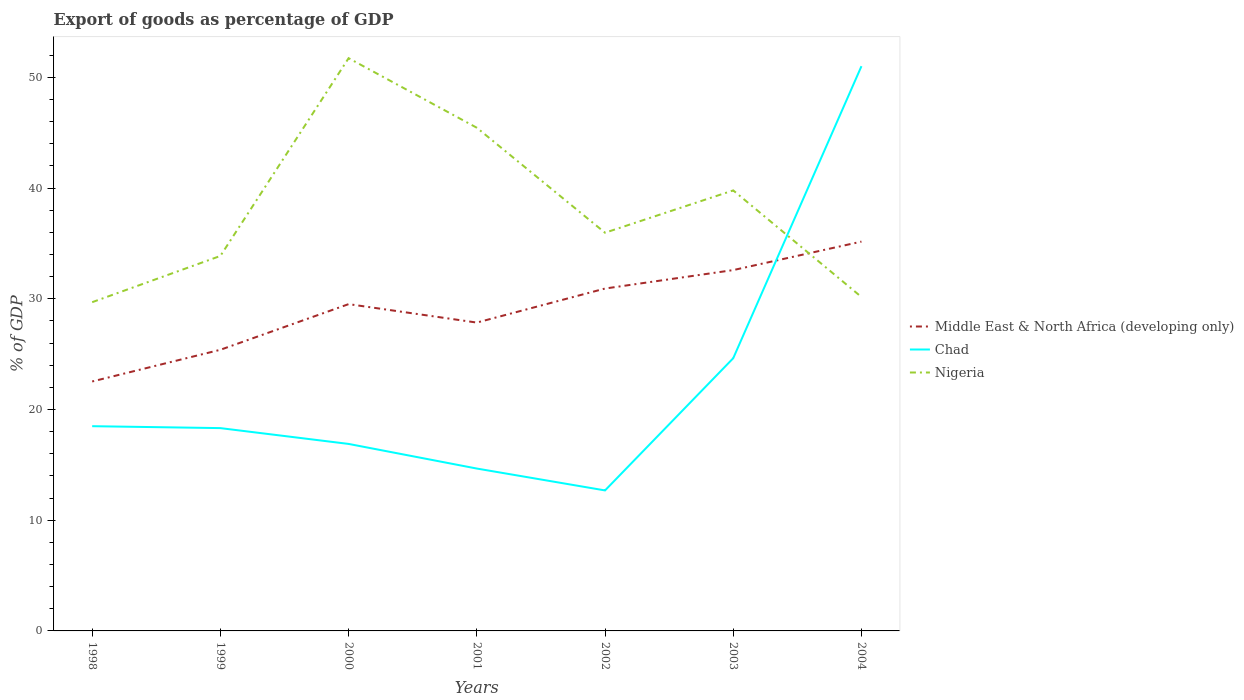Does the line corresponding to Nigeria intersect with the line corresponding to Middle East & North Africa (developing only)?
Give a very brief answer. Yes. Is the number of lines equal to the number of legend labels?
Your response must be concise. Yes. Across all years, what is the maximum export of goods as percentage of GDP in Middle East & North Africa (developing only)?
Give a very brief answer. 22.53. In which year was the export of goods as percentage of GDP in Chad maximum?
Keep it short and to the point. 2002. What is the total export of goods as percentage of GDP in Middle East & North Africa (developing only) in the graph?
Your answer should be very brief. -1.67. What is the difference between the highest and the second highest export of goods as percentage of GDP in Chad?
Your answer should be compact. 38.32. Does the graph contain grids?
Provide a succinct answer. No. How many legend labels are there?
Provide a succinct answer. 3. What is the title of the graph?
Your answer should be compact. Export of goods as percentage of GDP. What is the label or title of the X-axis?
Give a very brief answer. Years. What is the label or title of the Y-axis?
Make the answer very short. % of GDP. What is the % of GDP in Middle East & North Africa (developing only) in 1998?
Ensure brevity in your answer.  22.53. What is the % of GDP of Chad in 1998?
Make the answer very short. 18.49. What is the % of GDP in Nigeria in 1998?
Provide a succinct answer. 29.69. What is the % of GDP in Middle East & North Africa (developing only) in 1999?
Keep it short and to the point. 25.39. What is the % of GDP of Chad in 1999?
Your response must be concise. 18.32. What is the % of GDP of Nigeria in 1999?
Make the answer very short. 33.87. What is the % of GDP of Middle East & North Africa (developing only) in 2000?
Give a very brief answer. 29.52. What is the % of GDP in Chad in 2000?
Make the answer very short. 16.89. What is the % of GDP of Nigeria in 2000?
Keep it short and to the point. 51.73. What is the % of GDP in Middle East & North Africa (developing only) in 2001?
Your answer should be very brief. 27.85. What is the % of GDP in Chad in 2001?
Offer a terse response. 14.67. What is the % of GDP in Nigeria in 2001?
Your response must be concise. 45.45. What is the % of GDP in Middle East & North Africa (developing only) in 2002?
Offer a very short reply. 30.92. What is the % of GDP in Chad in 2002?
Your response must be concise. 12.69. What is the % of GDP in Nigeria in 2002?
Keep it short and to the point. 35.97. What is the % of GDP in Middle East & North Africa (developing only) in 2003?
Ensure brevity in your answer.  32.59. What is the % of GDP in Chad in 2003?
Your response must be concise. 24.63. What is the % of GDP of Nigeria in 2003?
Provide a succinct answer. 39.79. What is the % of GDP of Middle East & North Africa (developing only) in 2004?
Keep it short and to the point. 35.16. What is the % of GDP in Chad in 2004?
Keep it short and to the point. 51.01. What is the % of GDP of Nigeria in 2004?
Provide a succinct answer. 30.16. Across all years, what is the maximum % of GDP of Middle East & North Africa (developing only)?
Offer a very short reply. 35.16. Across all years, what is the maximum % of GDP of Chad?
Ensure brevity in your answer.  51.01. Across all years, what is the maximum % of GDP of Nigeria?
Provide a succinct answer. 51.73. Across all years, what is the minimum % of GDP of Middle East & North Africa (developing only)?
Provide a short and direct response. 22.53. Across all years, what is the minimum % of GDP in Chad?
Your response must be concise. 12.69. Across all years, what is the minimum % of GDP in Nigeria?
Offer a very short reply. 29.69. What is the total % of GDP of Middle East & North Africa (developing only) in the graph?
Ensure brevity in your answer.  203.97. What is the total % of GDP in Chad in the graph?
Offer a terse response. 156.7. What is the total % of GDP in Nigeria in the graph?
Provide a succinct answer. 266.65. What is the difference between the % of GDP of Middle East & North Africa (developing only) in 1998 and that in 1999?
Offer a very short reply. -2.86. What is the difference between the % of GDP of Chad in 1998 and that in 1999?
Ensure brevity in your answer.  0.17. What is the difference between the % of GDP of Nigeria in 1998 and that in 1999?
Give a very brief answer. -4.18. What is the difference between the % of GDP of Middle East & North Africa (developing only) in 1998 and that in 2000?
Offer a very short reply. -6.99. What is the difference between the % of GDP in Chad in 1998 and that in 2000?
Keep it short and to the point. 1.6. What is the difference between the % of GDP of Nigeria in 1998 and that in 2000?
Provide a short and direct response. -22.04. What is the difference between the % of GDP in Middle East & North Africa (developing only) in 1998 and that in 2001?
Give a very brief answer. -5.32. What is the difference between the % of GDP of Chad in 1998 and that in 2001?
Keep it short and to the point. 3.83. What is the difference between the % of GDP of Nigeria in 1998 and that in 2001?
Your response must be concise. -15.76. What is the difference between the % of GDP of Middle East & North Africa (developing only) in 1998 and that in 2002?
Provide a succinct answer. -8.39. What is the difference between the % of GDP in Chad in 1998 and that in 2002?
Your answer should be very brief. 5.8. What is the difference between the % of GDP in Nigeria in 1998 and that in 2002?
Offer a very short reply. -6.27. What is the difference between the % of GDP in Middle East & North Africa (developing only) in 1998 and that in 2003?
Offer a terse response. -10.06. What is the difference between the % of GDP in Chad in 1998 and that in 2003?
Provide a succinct answer. -6.14. What is the difference between the % of GDP in Nigeria in 1998 and that in 2003?
Provide a succinct answer. -10.1. What is the difference between the % of GDP of Middle East & North Africa (developing only) in 1998 and that in 2004?
Offer a very short reply. -12.63. What is the difference between the % of GDP of Chad in 1998 and that in 2004?
Ensure brevity in your answer.  -32.52. What is the difference between the % of GDP of Nigeria in 1998 and that in 2004?
Offer a very short reply. -0.47. What is the difference between the % of GDP of Middle East & North Africa (developing only) in 1999 and that in 2000?
Offer a very short reply. -4.12. What is the difference between the % of GDP in Chad in 1999 and that in 2000?
Make the answer very short. 1.43. What is the difference between the % of GDP in Nigeria in 1999 and that in 2000?
Your answer should be very brief. -17.86. What is the difference between the % of GDP of Middle East & North Africa (developing only) in 1999 and that in 2001?
Offer a terse response. -2.46. What is the difference between the % of GDP in Chad in 1999 and that in 2001?
Ensure brevity in your answer.  3.65. What is the difference between the % of GDP of Nigeria in 1999 and that in 2001?
Your answer should be very brief. -11.58. What is the difference between the % of GDP in Middle East & North Africa (developing only) in 1999 and that in 2002?
Offer a terse response. -5.53. What is the difference between the % of GDP in Chad in 1999 and that in 2002?
Ensure brevity in your answer.  5.63. What is the difference between the % of GDP of Nigeria in 1999 and that in 2002?
Ensure brevity in your answer.  -2.1. What is the difference between the % of GDP in Middle East & North Africa (developing only) in 1999 and that in 2003?
Your response must be concise. -7.2. What is the difference between the % of GDP in Chad in 1999 and that in 2003?
Offer a terse response. -6.31. What is the difference between the % of GDP in Nigeria in 1999 and that in 2003?
Make the answer very short. -5.92. What is the difference between the % of GDP in Middle East & North Africa (developing only) in 1999 and that in 2004?
Keep it short and to the point. -9.77. What is the difference between the % of GDP of Chad in 1999 and that in 2004?
Your answer should be compact. -32.69. What is the difference between the % of GDP of Nigeria in 1999 and that in 2004?
Provide a short and direct response. 3.71. What is the difference between the % of GDP in Middle East & North Africa (developing only) in 2000 and that in 2001?
Keep it short and to the point. 1.67. What is the difference between the % of GDP in Chad in 2000 and that in 2001?
Offer a terse response. 2.22. What is the difference between the % of GDP of Nigeria in 2000 and that in 2001?
Ensure brevity in your answer.  6.28. What is the difference between the % of GDP in Middle East & North Africa (developing only) in 2000 and that in 2002?
Your answer should be very brief. -1.41. What is the difference between the % of GDP of Chad in 2000 and that in 2002?
Your response must be concise. 4.2. What is the difference between the % of GDP of Nigeria in 2000 and that in 2002?
Give a very brief answer. 15.76. What is the difference between the % of GDP in Middle East & North Africa (developing only) in 2000 and that in 2003?
Keep it short and to the point. -3.08. What is the difference between the % of GDP in Chad in 2000 and that in 2003?
Offer a terse response. -7.74. What is the difference between the % of GDP in Nigeria in 2000 and that in 2003?
Ensure brevity in your answer.  11.94. What is the difference between the % of GDP of Middle East & North Africa (developing only) in 2000 and that in 2004?
Provide a succinct answer. -5.65. What is the difference between the % of GDP of Chad in 2000 and that in 2004?
Offer a very short reply. -34.12. What is the difference between the % of GDP of Nigeria in 2000 and that in 2004?
Your response must be concise. 21.57. What is the difference between the % of GDP of Middle East & North Africa (developing only) in 2001 and that in 2002?
Keep it short and to the point. -3.07. What is the difference between the % of GDP of Chad in 2001 and that in 2002?
Offer a terse response. 1.98. What is the difference between the % of GDP of Nigeria in 2001 and that in 2002?
Provide a succinct answer. 9.48. What is the difference between the % of GDP in Middle East & North Africa (developing only) in 2001 and that in 2003?
Your answer should be very brief. -4.74. What is the difference between the % of GDP of Chad in 2001 and that in 2003?
Your answer should be compact. -9.97. What is the difference between the % of GDP in Nigeria in 2001 and that in 2003?
Keep it short and to the point. 5.66. What is the difference between the % of GDP of Middle East & North Africa (developing only) in 2001 and that in 2004?
Provide a short and direct response. -7.31. What is the difference between the % of GDP in Chad in 2001 and that in 2004?
Offer a terse response. -36.34. What is the difference between the % of GDP in Nigeria in 2001 and that in 2004?
Ensure brevity in your answer.  15.29. What is the difference between the % of GDP of Middle East & North Africa (developing only) in 2002 and that in 2003?
Offer a terse response. -1.67. What is the difference between the % of GDP in Chad in 2002 and that in 2003?
Your answer should be very brief. -11.94. What is the difference between the % of GDP of Nigeria in 2002 and that in 2003?
Keep it short and to the point. -3.82. What is the difference between the % of GDP in Middle East & North Africa (developing only) in 2002 and that in 2004?
Give a very brief answer. -4.24. What is the difference between the % of GDP in Chad in 2002 and that in 2004?
Keep it short and to the point. -38.32. What is the difference between the % of GDP in Nigeria in 2002 and that in 2004?
Ensure brevity in your answer.  5.8. What is the difference between the % of GDP in Middle East & North Africa (developing only) in 2003 and that in 2004?
Make the answer very short. -2.57. What is the difference between the % of GDP of Chad in 2003 and that in 2004?
Your answer should be very brief. -26.38. What is the difference between the % of GDP of Nigeria in 2003 and that in 2004?
Ensure brevity in your answer.  9.63. What is the difference between the % of GDP in Middle East & North Africa (developing only) in 1998 and the % of GDP in Chad in 1999?
Provide a short and direct response. 4.21. What is the difference between the % of GDP in Middle East & North Africa (developing only) in 1998 and the % of GDP in Nigeria in 1999?
Make the answer very short. -11.34. What is the difference between the % of GDP in Chad in 1998 and the % of GDP in Nigeria in 1999?
Ensure brevity in your answer.  -15.38. What is the difference between the % of GDP in Middle East & North Africa (developing only) in 1998 and the % of GDP in Chad in 2000?
Make the answer very short. 5.64. What is the difference between the % of GDP in Middle East & North Africa (developing only) in 1998 and the % of GDP in Nigeria in 2000?
Your response must be concise. -29.2. What is the difference between the % of GDP of Chad in 1998 and the % of GDP of Nigeria in 2000?
Keep it short and to the point. -33.24. What is the difference between the % of GDP of Middle East & North Africa (developing only) in 1998 and the % of GDP of Chad in 2001?
Provide a short and direct response. 7.86. What is the difference between the % of GDP of Middle East & North Africa (developing only) in 1998 and the % of GDP of Nigeria in 2001?
Give a very brief answer. -22.92. What is the difference between the % of GDP of Chad in 1998 and the % of GDP of Nigeria in 2001?
Provide a succinct answer. -26.96. What is the difference between the % of GDP in Middle East & North Africa (developing only) in 1998 and the % of GDP in Chad in 2002?
Your answer should be compact. 9.84. What is the difference between the % of GDP in Middle East & North Africa (developing only) in 1998 and the % of GDP in Nigeria in 2002?
Your response must be concise. -13.44. What is the difference between the % of GDP of Chad in 1998 and the % of GDP of Nigeria in 2002?
Provide a short and direct response. -17.47. What is the difference between the % of GDP of Middle East & North Africa (developing only) in 1998 and the % of GDP of Chad in 2003?
Make the answer very short. -2.1. What is the difference between the % of GDP of Middle East & North Africa (developing only) in 1998 and the % of GDP of Nigeria in 2003?
Your response must be concise. -17.26. What is the difference between the % of GDP of Chad in 1998 and the % of GDP of Nigeria in 2003?
Your response must be concise. -21.3. What is the difference between the % of GDP of Middle East & North Africa (developing only) in 1998 and the % of GDP of Chad in 2004?
Offer a very short reply. -28.48. What is the difference between the % of GDP of Middle East & North Africa (developing only) in 1998 and the % of GDP of Nigeria in 2004?
Keep it short and to the point. -7.63. What is the difference between the % of GDP in Chad in 1998 and the % of GDP in Nigeria in 2004?
Keep it short and to the point. -11.67. What is the difference between the % of GDP of Middle East & North Africa (developing only) in 1999 and the % of GDP of Chad in 2000?
Keep it short and to the point. 8.5. What is the difference between the % of GDP in Middle East & North Africa (developing only) in 1999 and the % of GDP in Nigeria in 2000?
Your answer should be compact. -26.34. What is the difference between the % of GDP of Chad in 1999 and the % of GDP of Nigeria in 2000?
Your answer should be very brief. -33.41. What is the difference between the % of GDP in Middle East & North Africa (developing only) in 1999 and the % of GDP in Chad in 2001?
Ensure brevity in your answer.  10.73. What is the difference between the % of GDP in Middle East & North Africa (developing only) in 1999 and the % of GDP in Nigeria in 2001?
Give a very brief answer. -20.05. What is the difference between the % of GDP of Chad in 1999 and the % of GDP of Nigeria in 2001?
Your answer should be very brief. -27.13. What is the difference between the % of GDP in Middle East & North Africa (developing only) in 1999 and the % of GDP in Chad in 2002?
Provide a succinct answer. 12.7. What is the difference between the % of GDP in Middle East & North Africa (developing only) in 1999 and the % of GDP in Nigeria in 2002?
Your answer should be compact. -10.57. What is the difference between the % of GDP in Chad in 1999 and the % of GDP in Nigeria in 2002?
Ensure brevity in your answer.  -17.65. What is the difference between the % of GDP in Middle East & North Africa (developing only) in 1999 and the % of GDP in Chad in 2003?
Offer a very short reply. 0.76. What is the difference between the % of GDP in Middle East & North Africa (developing only) in 1999 and the % of GDP in Nigeria in 2003?
Offer a very short reply. -14.39. What is the difference between the % of GDP in Chad in 1999 and the % of GDP in Nigeria in 2003?
Make the answer very short. -21.47. What is the difference between the % of GDP in Middle East & North Africa (developing only) in 1999 and the % of GDP in Chad in 2004?
Your answer should be very brief. -25.62. What is the difference between the % of GDP of Middle East & North Africa (developing only) in 1999 and the % of GDP of Nigeria in 2004?
Provide a succinct answer. -4.77. What is the difference between the % of GDP in Chad in 1999 and the % of GDP in Nigeria in 2004?
Provide a succinct answer. -11.84. What is the difference between the % of GDP of Middle East & North Africa (developing only) in 2000 and the % of GDP of Chad in 2001?
Keep it short and to the point. 14.85. What is the difference between the % of GDP of Middle East & North Africa (developing only) in 2000 and the % of GDP of Nigeria in 2001?
Provide a short and direct response. -15.93. What is the difference between the % of GDP of Chad in 2000 and the % of GDP of Nigeria in 2001?
Offer a terse response. -28.56. What is the difference between the % of GDP in Middle East & North Africa (developing only) in 2000 and the % of GDP in Chad in 2002?
Your answer should be compact. 16.83. What is the difference between the % of GDP of Middle East & North Africa (developing only) in 2000 and the % of GDP of Nigeria in 2002?
Your answer should be very brief. -6.45. What is the difference between the % of GDP of Chad in 2000 and the % of GDP of Nigeria in 2002?
Offer a terse response. -19.08. What is the difference between the % of GDP in Middle East & North Africa (developing only) in 2000 and the % of GDP in Chad in 2003?
Your response must be concise. 4.88. What is the difference between the % of GDP in Middle East & North Africa (developing only) in 2000 and the % of GDP in Nigeria in 2003?
Keep it short and to the point. -10.27. What is the difference between the % of GDP of Chad in 2000 and the % of GDP of Nigeria in 2003?
Keep it short and to the point. -22.9. What is the difference between the % of GDP in Middle East & North Africa (developing only) in 2000 and the % of GDP in Chad in 2004?
Provide a succinct answer. -21.49. What is the difference between the % of GDP in Middle East & North Africa (developing only) in 2000 and the % of GDP in Nigeria in 2004?
Provide a succinct answer. -0.64. What is the difference between the % of GDP in Chad in 2000 and the % of GDP in Nigeria in 2004?
Give a very brief answer. -13.27. What is the difference between the % of GDP in Middle East & North Africa (developing only) in 2001 and the % of GDP in Chad in 2002?
Provide a succinct answer. 15.16. What is the difference between the % of GDP in Middle East & North Africa (developing only) in 2001 and the % of GDP in Nigeria in 2002?
Give a very brief answer. -8.12. What is the difference between the % of GDP of Chad in 2001 and the % of GDP of Nigeria in 2002?
Provide a short and direct response. -21.3. What is the difference between the % of GDP of Middle East & North Africa (developing only) in 2001 and the % of GDP of Chad in 2003?
Ensure brevity in your answer.  3.22. What is the difference between the % of GDP of Middle East & North Africa (developing only) in 2001 and the % of GDP of Nigeria in 2003?
Provide a short and direct response. -11.94. What is the difference between the % of GDP in Chad in 2001 and the % of GDP in Nigeria in 2003?
Ensure brevity in your answer.  -25.12. What is the difference between the % of GDP in Middle East & North Africa (developing only) in 2001 and the % of GDP in Chad in 2004?
Give a very brief answer. -23.16. What is the difference between the % of GDP in Middle East & North Africa (developing only) in 2001 and the % of GDP in Nigeria in 2004?
Provide a succinct answer. -2.31. What is the difference between the % of GDP of Chad in 2001 and the % of GDP of Nigeria in 2004?
Your answer should be compact. -15.49. What is the difference between the % of GDP of Middle East & North Africa (developing only) in 2002 and the % of GDP of Chad in 2003?
Give a very brief answer. 6.29. What is the difference between the % of GDP in Middle East & North Africa (developing only) in 2002 and the % of GDP in Nigeria in 2003?
Offer a very short reply. -8.86. What is the difference between the % of GDP of Chad in 2002 and the % of GDP of Nigeria in 2003?
Your answer should be compact. -27.1. What is the difference between the % of GDP in Middle East & North Africa (developing only) in 2002 and the % of GDP in Chad in 2004?
Offer a very short reply. -20.08. What is the difference between the % of GDP in Middle East & North Africa (developing only) in 2002 and the % of GDP in Nigeria in 2004?
Offer a terse response. 0.76. What is the difference between the % of GDP of Chad in 2002 and the % of GDP of Nigeria in 2004?
Keep it short and to the point. -17.47. What is the difference between the % of GDP in Middle East & North Africa (developing only) in 2003 and the % of GDP in Chad in 2004?
Provide a short and direct response. -18.42. What is the difference between the % of GDP of Middle East & North Africa (developing only) in 2003 and the % of GDP of Nigeria in 2004?
Offer a very short reply. 2.43. What is the difference between the % of GDP in Chad in 2003 and the % of GDP in Nigeria in 2004?
Offer a very short reply. -5.53. What is the average % of GDP of Middle East & North Africa (developing only) per year?
Offer a very short reply. 29.14. What is the average % of GDP of Chad per year?
Offer a very short reply. 22.39. What is the average % of GDP of Nigeria per year?
Provide a short and direct response. 38.09. In the year 1998, what is the difference between the % of GDP in Middle East & North Africa (developing only) and % of GDP in Chad?
Ensure brevity in your answer.  4.04. In the year 1998, what is the difference between the % of GDP of Middle East & North Africa (developing only) and % of GDP of Nigeria?
Offer a very short reply. -7.16. In the year 1998, what is the difference between the % of GDP in Chad and % of GDP in Nigeria?
Your answer should be very brief. -11.2. In the year 1999, what is the difference between the % of GDP in Middle East & North Africa (developing only) and % of GDP in Chad?
Provide a short and direct response. 7.08. In the year 1999, what is the difference between the % of GDP of Middle East & North Africa (developing only) and % of GDP of Nigeria?
Give a very brief answer. -8.48. In the year 1999, what is the difference between the % of GDP of Chad and % of GDP of Nigeria?
Make the answer very short. -15.55. In the year 2000, what is the difference between the % of GDP in Middle East & North Africa (developing only) and % of GDP in Chad?
Keep it short and to the point. 12.63. In the year 2000, what is the difference between the % of GDP in Middle East & North Africa (developing only) and % of GDP in Nigeria?
Your answer should be very brief. -22.21. In the year 2000, what is the difference between the % of GDP in Chad and % of GDP in Nigeria?
Give a very brief answer. -34.84. In the year 2001, what is the difference between the % of GDP in Middle East & North Africa (developing only) and % of GDP in Chad?
Keep it short and to the point. 13.18. In the year 2001, what is the difference between the % of GDP in Middle East & North Africa (developing only) and % of GDP in Nigeria?
Your answer should be compact. -17.6. In the year 2001, what is the difference between the % of GDP of Chad and % of GDP of Nigeria?
Provide a succinct answer. -30.78. In the year 2002, what is the difference between the % of GDP of Middle East & North Africa (developing only) and % of GDP of Chad?
Ensure brevity in your answer.  18.23. In the year 2002, what is the difference between the % of GDP of Middle East & North Africa (developing only) and % of GDP of Nigeria?
Ensure brevity in your answer.  -5.04. In the year 2002, what is the difference between the % of GDP of Chad and % of GDP of Nigeria?
Give a very brief answer. -23.28. In the year 2003, what is the difference between the % of GDP of Middle East & North Africa (developing only) and % of GDP of Chad?
Offer a very short reply. 7.96. In the year 2003, what is the difference between the % of GDP in Middle East & North Africa (developing only) and % of GDP in Nigeria?
Ensure brevity in your answer.  -7.2. In the year 2003, what is the difference between the % of GDP of Chad and % of GDP of Nigeria?
Your answer should be very brief. -15.15. In the year 2004, what is the difference between the % of GDP of Middle East & North Africa (developing only) and % of GDP of Chad?
Your answer should be compact. -15.85. In the year 2004, what is the difference between the % of GDP in Middle East & North Africa (developing only) and % of GDP in Nigeria?
Give a very brief answer. 5. In the year 2004, what is the difference between the % of GDP of Chad and % of GDP of Nigeria?
Offer a very short reply. 20.85. What is the ratio of the % of GDP of Middle East & North Africa (developing only) in 1998 to that in 1999?
Provide a succinct answer. 0.89. What is the ratio of the % of GDP of Chad in 1998 to that in 1999?
Make the answer very short. 1.01. What is the ratio of the % of GDP in Nigeria in 1998 to that in 1999?
Give a very brief answer. 0.88. What is the ratio of the % of GDP of Middle East & North Africa (developing only) in 1998 to that in 2000?
Your answer should be compact. 0.76. What is the ratio of the % of GDP of Chad in 1998 to that in 2000?
Ensure brevity in your answer.  1.09. What is the ratio of the % of GDP in Nigeria in 1998 to that in 2000?
Your answer should be compact. 0.57. What is the ratio of the % of GDP in Middle East & North Africa (developing only) in 1998 to that in 2001?
Make the answer very short. 0.81. What is the ratio of the % of GDP of Chad in 1998 to that in 2001?
Ensure brevity in your answer.  1.26. What is the ratio of the % of GDP of Nigeria in 1998 to that in 2001?
Provide a short and direct response. 0.65. What is the ratio of the % of GDP in Middle East & North Africa (developing only) in 1998 to that in 2002?
Your answer should be very brief. 0.73. What is the ratio of the % of GDP in Chad in 1998 to that in 2002?
Your answer should be compact. 1.46. What is the ratio of the % of GDP of Nigeria in 1998 to that in 2002?
Offer a very short reply. 0.83. What is the ratio of the % of GDP in Middle East & North Africa (developing only) in 1998 to that in 2003?
Make the answer very short. 0.69. What is the ratio of the % of GDP of Chad in 1998 to that in 2003?
Ensure brevity in your answer.  0.75. What is the ratio of the % of GDP of Nigeria in 1998 to that in 2003?
Give a very brief answer. 0.75. What is the ratio of the % of GDP of Middle East & North Africa (developing only) in 1998 to that in 2004?
Keep it short and to the point. 0.64. What is the ratio of the % of GDP in Chad in 1998 to that in 2004?
Offer a very short reply. 0.36. What is the ratio of the % of GDP in Nigeria in 1998 to that in 2004?
Your answer should be very brief. 0.98. What is the ratio of the % of GDP of Middle East & North Africa (developing only) in 1999 to that in 2000?
Provide a short and direct response. 0.86. What is the ratio of the % of GDP of Chad in 1999 to that in 2000?
Ensure brevity in your answer.  1.08. What is the ratio of the % of GDP in Nigeria in 1999 to that in 2000?
Keep it short and to the point. 0.65. What is the ratio of the % of GDP of Middle East & North Africa (developing only) in 1999 to that in 2001?
Make the answer very short. 0.91. What is the ratio of the % of GDP in Chad in 1999 to that in 2001?
Your answer should be very brief. 1.25. What is the ratio of the % of GDP of Nigeria in 1999 to that in 2001?
Make the answer very short. 0.75. What is the ratio of the % of GDP in Middle East & North Africa (developing only) in 1999 to that in 2002?
Your answer should be very brief. 0.82. What is the ratio of the % of GDP in Chad in 1999 to that in 2002?
Your response must be concise. 1.44. What is the ratio of the % of GDP in Nigeria in 1999 to that in 2002?
Make the answer very short. 0.94. What is the ratio of the % of GDP in Middle East & North Africa (developing only) in 1999 to that in 2003?
Make the answer very short. 0.78. What is the ratio of the % of GDP of Chad in 1999 to that in 2003?
Give a very brief answer. 0.74. What is the ratio of the % of GDP of Nigeria in 1999 to that in 2003?
Offer a very short reply. 0.85. What is the ratio of the % of GDP in Middle East & North Africa (developing only) in 1999 to that in 2004?
Provide a short and direct response. 0.72. What is the ratio of the % of GDP of Chad in 1999 to that in 2004?
Offer a very short reply. 0.36. What is the ratio of the % of GDP of Nigeria in 1999 to that in 2004?
Make the answer very short. 1.12. What is the ratio of the % of GDP of Middle East & North Africa (developing only) in 2000 to that in 2001?
Keep it short and to the point. 1.06. What is the ratio of the % of GDP in Chad in 2000 to that in 2001?
Provide a short and direct response. 1.15. What is the ratio of the % of GDP of Nigeria in 2000 to that in 2001?
Make the answer very short. 1.14. What is the ratio of the % of GDP of Middle East & North Africa (developing only) in 2000 to that in 2002?
Your response must be concise. 0.95. What is the ratio of the % of GDP in Chad in 2000 to that in 2002?
Make the answer very short. 1.33. What is the ratio of the % of GDP of Nigeria in 2000 to that in 2002?
Your answer should be very brief. 1.44. What is the ratio of the % of GDP of Middle East & North Africa (developing only) in 2000 to that in 2003?
Ensure brevity in your answer.  0.91. What is the ratio of the % of GDP of Chad in 2000 to that in 2003?
Give a very brief answer. 0.69. What is the ratio of the % of GDP in Nigeria in 2000 to that in 2003?
Your answer should be very brief. 1.3. What is the ratio of the % of GDP in Middle East & North Africa (developing only) in 2000 to that in 2004?
Offer a terse response. 0.84. What is the ratio of the % of GDP of Chad in 2000 to that in 2004?
Your answer should be compact. 0.33. What is the ratio of the % of GDP of Nigeria in 2000 to that in 2004?
Keep it short and to the point. 1.72. What is the ratio of the % of GDP in Middle East & North Africa (developing only) in 2001 to that in 2002?
Offer a very short reply. 0.9. What is the ratio of the % of GDP in Chad in 2001 to that in 2002?
Offer a very short reply. 1.16. What is the ratio of the % of GDP of Nigeria in 2001 to that in 2002?
Keep it short and to the point. 1.26. What is the ratio of the % of GDP of Middle East & North Africa (developing only) in 2001 to that in 2003?
Keep it short and to the point. 0.85. What is the ratio of the % of GDP of Chad in 2001 to that in 2003?
Your answer should be very brief. 0.6. What is the ratio of the % of GDP of Nigeria in 2001 to that in 2003?
Offer a very short reply. 1.14. What is the ratio of the % of GDP of Middle East & North Africa (developing only) in 2001 to that in 2004?
Your answer should be very brief. 0.79. What is the ratio of the % of GDP of Chad in 2001 to that in 2004?
Ensure brevity in your answer.  0.29. What is the ratio of the % of GDP of Nigeria in 2001 to that in 2004?
Your answer should be very brief. 1.51. What is the ratio of the % of GDP in Middle East & North Africa (developing only) in 2002 to that in 2003?
Your answer should be very brief. 0.95. What is the ratio of the % of GDP of Chad in 2002 to that in 2003?
Offer a very short reply. 0.52. What is the ratio of the % of GDP of Nigeria in 2002 to that in 2003?
Your answer should be very brief. 0.9. What is the ratio of the % of GDP in Middle East & North Africa (developing only) in 2002 to that in 2004?
Provide a short and direct response. 0.88. What is the ratio of the % of GDP in Chad in 2002 to that in 2004?
Provide a short and direct response. 0.25. What is the ratio of the % of GDP of Nigeria in 2002 to that in 2004?
Your answer should be compact. 1.19. What is the ratio of the % of GDP in Middle East & North Africa (developing only) in 2003 to that in 2004?
Offer a very short reply. 0.93. What is the ratio of the % of GDP of Chad in 2003 to that in 2004?
Offer a very short reply. 0.48. What is the ratio of the % of GDP in Nigeria in 2003 to that in 2004?
Keep it short and to the point. 1.32. What is the difference between the highest and the second highest % of GDP of Middle East & North Africa (developing only)?
Provide a succinct answer. 2.57. What is the difference between the highest and the second highest % of GDP in Chad?
Your answer should be very brief. 26.38. What is the difference between the highest and the second highest % of GDP in Nigeria?
Make the answer very short. 6.28. What is the difference between the highest and the lowest % of GDP in Middle East & North Africa (developing only)?
Offer a very short reply. 12.63. What is the difference between the highest and the lowest % of GDP of Chad?
Offer a very short reply. 38.32. What is the difference between the highest and the lowest % of GDP in Nigeria?
Your answer should be compact. 22.04. 